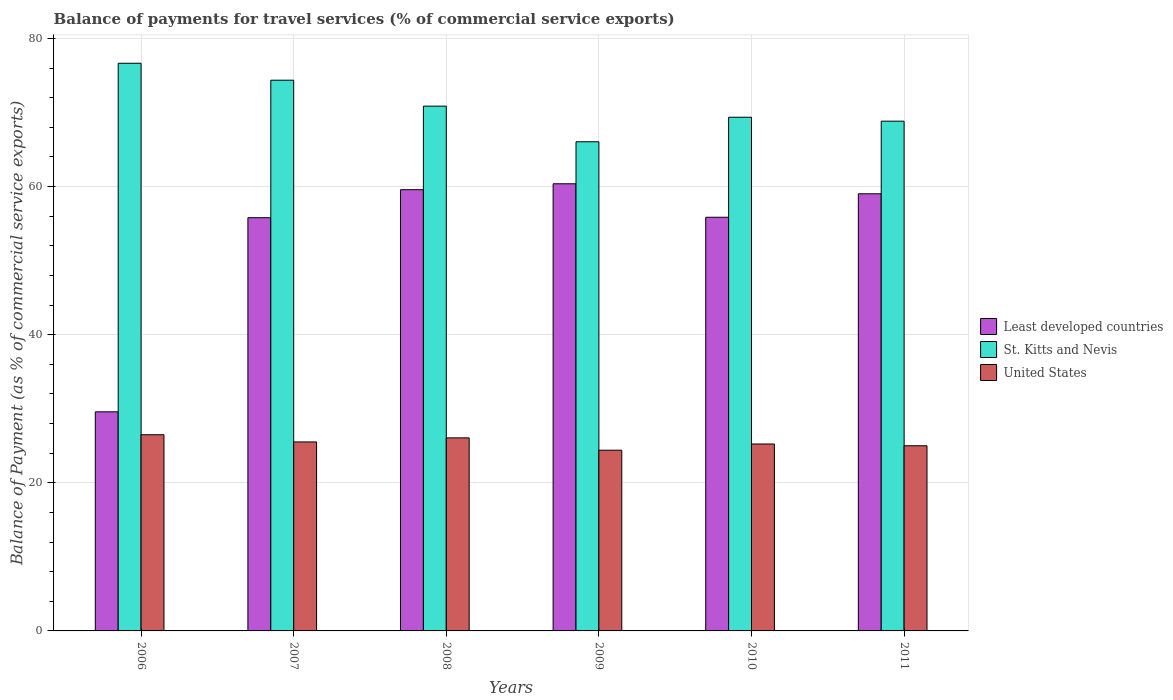How many different coloured bars are there?
Your answer should be very brief. 3. Are the number of bars on each tick of the X-axis equal?
Offer a very short reply. Yes. How many bars are there on the 2nd tick from the right?
Give a very brief answer. 3. What is the balance of payments for travel services in United States in 2009?
Your response must be concise. 24.4. Across all years, what is the maximum balance of payments for travel services in St. Kitts and Nevis?
Your response must be concise. 76.64. Across all years, what is the minimum balance of payments for travel services in Least developed countries?
Provide a short and direct response. 29.58. In which year was the balance of payments for travel services in Least developed countries minimum?
Keep it short and to the point. 2006. What is the total balance of payments for travel services in St. Kitts and Nevis in the graph?
Provide a succinct answer. 426.08. What is the difference between the balance of payments for travel services in United States in 2007 and that in 2010?
Offer a very short reply. 0.28. What is the difference between the balance of payments for travel services in United States in 2008 and the balance of payments for travel services in St. Kitts and Nevis in 2010?
Your response must be concise. -43.29. What is the average balance of payments for travel services in United States per year?
Give a very brief answer. 25.45. In the year 2008, what is the difference between the balance of payments for travel services in United States and balance of payments for travel services in Least developed countries?
Offer a very short reply. -33.51. What is the ratio of the balance of payments for travel services in St. Kitts and Nevis in 2009 to that in 2010?
Offer a terse response. 0.95. Is the balance of payments for travel services in United States in 2006 less than that in 2008?
Provide a short and direct response. No. What is the difference between the highest and the second highest balance of payments for travel services in United States?
Offer a very short reply. 0.42. What is the difference between the highest and the lowest balance of payments for travel services in St. Kitts and Nevis?
Keep it short and to the point. 10.6. In how many years, is the balance of payments for travel services in Least developed countries greater than the average balance of payments for travel services in Least developed countries taken over all years?
Ensure brevity in your answer.  5. Is the sum of the balance of payments for travel services in Least developed countries in 2008 and 2009 greater than the maximum balance of payments for travel services in St. Kitts and Nevis across all years?
Your answer should be very brief. Yes. What does the 1st bar from the left in 2008 represents?
Your response must be concise. Least developed countries. What does the 2nd bar from the right in 2009 represents?
Give a very brief answer. St. Kitts and Nevis. Is it the case that in every year, the sum of the balance of payments for travel services in St. Kitts and Nevis and balance of payments for travel services in United States is greater than the balance of payments for travel services in Least developed countries?
Offer a very short reply. Yes. How many bars are there?
Provide a short and direct response. 18. Are all the bars in the graph horizontal?
Provide a succinct answer. No. How many years are there in the graph?
Your answer should be very brief. 6. How many legend labels are there?
Ensure brevity in your answer.  3. What is the title of the graph?
Your answer should be very brief. Balance of payments for travel services (% of commercial service exports). Does "St. Kitts and Nevis" appear as one of the legend labels in the graph?
Offer a terse response. Yes. What is the label or title of the Y-axis?
Provide a short and direct response. Balance of Payment (as % of commercial service exports). What is the Balance of Payment (as % of commercial service exports) in Least developed countries in 2006?
Give a very brief answer. 29.58. What is the Balance of Payment (as % of commercial service exports) of St. Kitts and Nevis in 2006?
Keep it short and to the point. 76.64. What is the Balance of Payment (as % of commercial service exports) in United States in 2006?
Your answer should be very brief. 26.49. What is the Balance of Payment (as % of commercial service exports) in Least developed countries in 2007?
Your answer should be compact. 55.79. What is the Balance of Payment (as % of commercial service exports) in St. Kitts and Nevis in 2007?
Your answer should be very brief. 74.35. What is the Balance of Payment (as % of commercial service exports) in United States in 2007?
Make the answer very short. 25.52. What is the Balance of Payment (as % of commercial service exports) of Least developed countries in 2008?
Your answer should be very brief. 59.57. What is the Balance of Payment (as % of commercial service exports) of St. Kitts and Nevis in 2008?
Keep it short and to the point. 70.86. What is the Balance of Payment (as % of commercial service exports) in United States in 2008?
Provide a short and direct response. 26.07. What is the Balance of Payment (as % of commercial service exports) of Least developed countries in 2009?
Provide a short and direct response. 60.37. What is the Balance of Payment (as % of commercial service exports) of St. Kitts and Nevis in 2009?
Provide a short and direct response. 66.05. What is the Balance of Payment (as % of commercial service exports) in United States in 2009?
Ensure brevity in your answer.  24.4. What is the Balance of Payment (as % of commercial service exports) in Least developed countries in 2010?
Offer a very short reply. 55.85. What is the Balance of Payment (as % of commercial service exports) in St. Kitts and Nevis in 2010?
Provide a short and direct response. 69.36. What is the Balance of Payment (as % of commercial service exports) in United States in 2010?
Provide a succinct answer. 25.24. What is the Balance of Payment (as % of commercial service exports) in Least developed countries in 2011?
Offer a terse response. 59.02. What is the Balance of Payment (as % of commercial service exports) of St. Kitts and Nevis in 2011?
Ensure brevity in your answer.  68.82. What is the Balance of Payment (as % of commercial service exports) of United States in 2011?
Ensure brevity in your answer.  25. Across all years, what is the maximum Balance of Payment (as % of commercial service exports) in Least developed countries?
Ensure brevity in your answer.  60.37. Across all years, what is the maximum Balance of Payment (as % of commercial service exports) of St. Kitts and Nevis?
Your answer should be compact. 76.64. Across all years, what is the maximum Balance of Payment (as % of commercial service exports) of United States?
Offer a terse response. 26.49. Across all years, what is the minimum Balance of Payment (as % of commercial service exports) in Least developed countries?
Offer a terse response. 29.58. Across all years, what is the minimum Balance of Payment (as % of commercial service exports) in St. Kitts and Nevis?
Provide a succinct answer. 66.05. Across all years, what is the minimum Balance of Payment (as % of commercial service exports) of United States?
Ensure brevity in your answer.  24.4. What is the total Balance of Payment (as % of commercial service exports) of Least developed countries in the graph?
Your answer should be compact. 320.19. What is the total Balance of Payment (as % of commercial service exports) in St. Kitts and Nevis in the graph?
Ensure brevity in your answer.  426.08. What is the total Balance of Payment (as % of commercial service exports) in United States in the graph?
Provide a succinct answer. 152.71. What is the difference between the Balance of Payment (as % of commercial service exports) of Least developed countries in 2006 and that in 2007?
Your answer should be very brief. -26.21. What is the difference between the Balance of Payment (as % of commercial service exports) of St. Kitts and Nevis in 2006 and that in 2007?
Offer a terse response. 2.29. What is the difference between the Balance of Payment (as % of commercial service exports) in United States in 2006 and that in 2007?
Make the answer very short. 0.97. What is the difference between the Balance of Payment (as % of commercial service exports) in Least developed countries in 2006 and that in 2008?
Provide a short and direct response. -29.99. What is the difference between the Balance of Payment (as % of commercial service exports) in St. Kitts and Nevis in 2006 and that in 2008?
Make the answer very short. 5.79. What is the difference between the Balance of Payment (as % of commercial service exports) of United States in 2006 and that in 2008?
Your answer should be compact. 0.42. What is the difference between the Balance of Payment (as % of commercial service exports) in Least developed countries in 2006 and that in 2009?
Ensure brevity in your answer.  -30.79. What is the difference between the Balance of Payment (as % of commercial service exports) in St. Kitts and Nevis in 2006 and that in 2009?
Your answer should be very brief. 10.6. What is the difference between the Balance of Payment (as % of commercial service exports) in United States in 2006 and that in 2009?
Offer a very short reply. 2.09. What is the difference between the Balance of Payment (as % of commercial service exports) in Least developed countries in 2006 and that in 2010?
Offer a terse response. -26.27. What is the difference between the Balance of Payment (as % of commercial service exports) of St. Kitts and Nevis in 2006 and that in 2010?
Give a very brief answer. 7.29. What is the difference between the Balance of Payment (as % of commercial service exports) of United States in 2006 and that in 2010?
Offer a terse response. 1.25. What is the difference between the Balance of Payment (as % of commercial service exports) in Least developed countries in 2006 and that in 2011?
Offer a very short reply. -29.44. What is the difference between the Balance of Payment (as % of commercial service exports) in St. Kitts and Nevis in 2006 and that in 2011?
Offer a terse response. 7.82. What is the difference between the Balance of Payment (as % of commercial service exports) of United States in 2006 and that in 2011?
Give a very brief answer. 1.49. What is the difference between the Balance of Payment (as % of commercial service exports) in Least developed countries in 2007 and that in 2008?
Your answer should be very brief. -3.78. What is the difference between the Balance of Payment (as % of commercial service exports) in St. Kitts and Nevis in 2007 and that in 2008?
Your response must be concise. 3.5. What is the difference between the Balance of Payment (as % of commercial service exports) in United States in 2007 and that in 2008?
Offer a terse response. -0.55. What is the difference between the Balance of Payment (as % of commercial service exports) in Least developed countries in 2007 and that in 2009?
Keep it short and to the point. -4.58. What is the difference between the Balance of Payment (as % of commercial service exports) of St. Kitts and Nevis in 2007 and that in 2009?
Provide a succinct answer. 8.31. What is the difference between the Balance of Payment (as % of commercial service exports) of United States in 2007 and that in 2009?
Provide a short and direct response. 1.12. What is the difference between the Balance of Payment (as % of commercial service exports) in Least developed countries in 2007 and that in 2010?
Provide a short and direct response. -0.06. What is the difference between the Balance of Payment (as % of commercial service exports) of St. Kitts and Nevis in 2007 and that in 2010?
Your response must be concise. 5. What is the difference between the Balance of Payment (as % of commercial service exports) of United States in 2007 and that in 2010?
Your answer should be very brief. 0.28. What is the difference between the Balance of Payment (as % of commercial service exports) of Least developed countries in 2007 and that in 2011?
Give a very brief answer. -3.23. What is the difference between the Balance of Payment (as % of commercial service exports) of St. Kitts and Nevis in 2007 and that in 2011?
Ensure brevity in your answer.  5.53. What is the difference between the Balance of Payment (as % of commercial service exports) in United States in 2007 and that in 2011?
Keep it short and to the point. 0.51. What is the difference between the Balance of Payment (as % of commercial service exports) in Least developed countries in 2008 and that in 2009?
Your response must be concise. -0.8. What is the difference between the Balance of Payment (as % of commercial service exports) in St. Kitts and Nevis in 2008 and that in 2009?
Your answer should be very brief. 4.81. What is the difference between the Balance of Payment (as % of commercial service exports) of United States in 2008 and that in 2009?
Give a very brief answer. 1.67. What is the difference between the Balance of Payment (as % of commercial service exports) of Least developed countries in 2008 and that in 2010?
Provide a succinct answer. 3.72. What is the difference between the Balance of Payment (as % of commercial service exports) in St. Kitts and Nevis in 2008 and that in 2010?
Keep it short and to the point. 1.5. What is the difference between the Balance of Payment (as % of commercial service exports) of United States in 2008 and that in 2010?
Offer a terse response. 0.83. What is the difference between the Balance of Payment (as % of commercial service exports) in Least developed countries in 2008 and that in 2011?
Provide a short and direct response. 0.55. What is the difference between the Balance of Payment (as % of commercial service exports) of St. Kitts and Nevis in 2008 and that in 2011?
Your answer should be compact. 2.03. What is the difference between the Balance of Payment (as % of commercial service exports) in United States in 2008 and that in 2011?
Make the answer very short. 1.07. What is the difference between the Balance of Payment (as % of commercial service exports) of Least developed countries in 2009 and that in 2010?
Keep it short and to the point. 4.52. What is the difference between the Balance of Payment (as % of commercial service exports) of St. Kitts and Nevis in 2009 and that in 2010?
Your answer should be compact. -3.31. What is the difference between the Balance of Payment (as % of commercial service exports) in United States in 2009 and that in 2010?
Your response must be concise. -0.84. What is the difference between the Balance of Payment (as % of commercial service exports) of Least developed countries in 2009 and that in 2011?
Provide a short and direct response. 1.35. What is the difference between the Balance of Payment (as % of commercial service exports) of St. Kitts and Nevis in 2009 and that in 2011?
Give a very brief answer. -2.78. What is the difference between the Balance of Payment (as % of commercial service exports) of United States in 2009 and that in 2011?
Keep it short and to the point. -0.6. What is the difference between the Balance of Payment (as % of commercial service exports) of Least developed countries in 2010 and that in 2011?
Provide a short and direct response. -3.17. What is the difference between the Balance of Payment (as % of commercial service exports) in St. Kitts and Nevis in 2010 and that in 2011?
Your answer should be compact. 0.53. What is the difference between the Balance of Payment (as % of commercial service exports) in United States in 2010 and that in 2011?
Provide a succinct answer. 0.24. What is the difference between the Balance of Payment (as % of commercial service exports) of Least developed countries in 2006 and the Balance of Payment (as % of commercial service exports) of St. Kitts and Nevis in 2007?
Your answer should be compact. -44.77. What is the difference between the Balance of Payment (as % of commercial service exports) in Least developed countries in 2006 and the Balance of Payment (as % of commercial service exports) in United States in 2007?
Make the answer very short. 4.06. What is the difference between the Balance of Payment (as % of commercial service exports) of St. Kitts and Nevis in 2006 and the Balance of Payment (as % of commercial service exports) of United States in 2007?
Ensure brevity in your answer.  51.13. What is the difference between the Balance of Payment (as % of commercial service exports) in Least developed countries in 2006 and the Balance of Payment (as % of commercial service exports) in St. Kitts and Nevis in 2008?
Keep it short and to the point. -41.27. What is the difference between the Balance of Payment (as % of commercial service exports) in Least developed countries in 2006 and the Balance of Payment (as % of commercial service exports) in United States in 2008?
Offer a terse response. 3.51. What is the difference between the Balance of Payment (as % of commercial service exports) in St. Kitts and Nevis in 2006 and the Balance of Payment (as % of commercial service exports) in United States in 2008?
Ensure brevity in your answer.  50.58. What is the difference between the Balance of Payment (as % of commercial service exports) of Least developed countries in 2006 and the Balance of Payment (as % of commercial service exports) of St. Kitts and Nevis in 2009?
Ensure brevity in your answer.  -36.46. What is the difference between the Balance of Payment (as % of commercial service exports) of Least developed countries in 2006 and the Balance of Payment (as % of commercial service exports) of United States in 2009?
Your answer should be compact. 5.18. What is the difference between the Balance of Payment (as % of commercial service exports) in St. Kitts and Nevis in 2006 and the Balance of Payment (as % of commercial service exports) in United States in 2009?
Your response must be concise. 52.24. What is the difference between the Balance of Payment (as % of commercial service exports) of Least developed countries in 2006 and the Balance of Payment (as % of commercial service exports) of St. Kitts and Nevis in 2010?
Your answer should be very brief. -39.77. What is the difference between the Balance of Payment (as % of commercial service exports) in Least developed countries in 2006 and the Balance of Payment (as % of commercial service exports) in United States in 2010?
Keep it short and to the point. 4.34. What is the difference between the Balance of Payment (as % of commercial service exports) of St. Kitts and Nevis in 2006 and the Balance of Payment (as % of commercial service exports) of United States in 2010?
Offer a very short reply. 51.41. What is the difference between the Balance of Payment (as % of commercial service exports) of Least developed countries in 2006 and the Balance of Payment (as % of commercial service exports) of St. Kitts and Nevis in 2011?
Offer a terse response. -39.24. What is the difference between the Balance of Payment (as % of commercial service exports) in Least developed countries in 2006 and the Balance of Payment (as % of commercial service exports) in United States in 2011?
Offer a terse response. 4.58. What is the difference between the Balance of Payment (as % of commercial service exports) of St. Kitts and Nevis in 2006 and the Balance of Payment (as % of commercial service exports) of United States in 2011?
Provide a short and direct response. 51.64. What is the difference between the Balance of Payment (as % of commercial service exports) of Least developed countries in 2007 and the Balance of Payment (as % of commercial service exports) of St. Kitts and Nevis in 2008?
Make the answer very short. -15.06. What is the difference between the Balance of Payment (as % of commercial service exports) of Least developed countries in 2007 and the Balance of Payment (as % of commercial service exports) of United States in 2008?
Ensure brevity in your answer.  29.73. What is the difference between the Balance of Payment (as % of commercial service exports) of St. Kitts and Nevis in 2007 and the Balance of Payment (as % of commercial service exports) of United States in 2008?
Offer a very short reply. 48.29. What is the difference between the Balance of Payment (as % of commercial service exports) in Least developed countries in 2007 and the Balance of Payment (as % of commercial service exports) in St. Kitts and Nevis in 2009?
Provide a short and direct response. -10.25. What is the difference between the Balance of Payment (as % of commercial service exports) of Least developed countries in 2007 and the Balance of Payment (as % of commercial service exports) of United States in 2009?
Give a very brief answer. 31.39. What is the difference between the Balance of Payment (as % of commercial service exports) in St. Kitts and Nevis in 2007 and the Balance of Payment (as % of commercial service exports) in United States in 2009?
Offer a terse response. 49.96. What is the difference between the Balance of Payment (as % of commercial service exports) of Least developed countries in 2007 and the Balance of Payment (as % of commercial service exports) of St. Kitts and Nevis in 2010?
Your answer should be compact. -13.56. What is the difference between the Balance of Payment (as % of commercial service exports) of Least developed countries in 2007 and the Balance of Payment (as % of commercial service exports) of United States in 2010?
Keep it short and to the point. 30.55. What is the difference between the Balance of Payment (as % of commercial service exports) in St. Kitts and Nevis in 2007 and the Balance of Payment (as % of commercial service exports) in United States in 2010?
Provide a succinct answer. 49.12. What is the difference between the Balance of Payment (as % of commercial service exports) in Least developed countries in 2007 and the Balance of Payment (as % of commercial service exports) in St. Kitts and Nevis in 2011?
Ensure brevity in your answer.  -13.03. What is the difference between the Balance of Payment (as % of commercial service exports) in Least developed countries in 2007 and the Balance of Payment (as % of commercial service exports) in United States in 2011?
Your answer should be very brief. 30.79. What is the difference between the Balance of Payment (as % of commercial service exports) in St. Kitts and Nevis in 2007 and the Balance of Payment (as % of commercial service exports) in United States in 2011?
Give a very brief answer. 49.35. What is the difference between the Balance of Payment (as % of commercial service exports) in Least developed countries in 2008 and the Balance of Payment (as % of commercial service exports) in St. Kitts and Nevis in 2009?
Your answer should be very brief. -6.47. What is the difference between the Balance of Payment (as % of commercial service exports) of Least developed countries in 2008 and the Balance of Payment (as % of commercial service exports) of United States in 2009?
Your response must be concise. 35.17. What is the difference between the Balance of Payment (as % of commercial service exports) of St. Kitts and Nevis in 2008 and the Balance of Payment (as % of commercial service exports) of United States in 2009?
Keep it short and to the point. 46.46. What is the difference between the Balance of Payment (as % of commercial service exports) in Least developed countries in 2008 and the Balance of Payment (as % of commercial service exports) in St. Kitts and Nevis in 2010?
Provide a short and direct response. -9.78. What is the difference between the Balance of Payment (as % of commercial service exports) in Least developed countries in 2008 and the Balance of Payment (as % of commercial service exports) in United States in 2010?
Provide a succinct answer. 34.34. What is the difference between the Balance of Payment (as % of commercial service exports) of St. Kitts and Nevis in 2008 and the Balance of Payment (as % of commercial service exports) of United States in 2010?
Ensure brevity in your answer.  45.62. What is the difference between the Balance of Payment (as % of commercial service exports) in Least developed countries in 2008 and the Balance of Payment (as % of commercial service exports) in St. Kitts and Nevis in 2011?
Your answer should be very brief. -9.25. What is the difference between the Balance of Payment (as % of commercial service exports) of Least developed countries in 2008 and the Balance of Payment (as % of commercial service exports) of United States in 2011?
Give a very brief answer. 34.57. What is the difference between the Balance of Payment (as % of commercial service exports) in St. Kitts and Nevis in 2008 and the Balance of Payment (as % of commercial service exports) in United States in 2011?
Provide a short and direct response. 45.85. What is the difference between the Balance of Payment (as % of commercial service exports) of Least developed countries in 2009 and the Balance of Payment (as % of commercial service exports) of St. Kitts and Nevis in 2010?
Provide a succinct answer. -8.98. What is the difference between the Balance of Payment (as % of commercial service exports) in Least developed countries in 2009 and the Balance of Payment (as % of commercial service exports) in United States in 2010?
Offer a terse response. 35.13. What is the difference between the Balance of Payment (as % of commercial service exports) of St. Kitts and Nevis in 2009 and the Balance of Payment (as % of commercial service exports) of United States in 2010?
Provide a short and direct response. 40.81. What is the difference between the Balance of Payment (as % of commercial service exports) in Least developed countries in 2009 and the Balance of Payment (as % of commercial service exports) in St. Kitts and Nevis in 2011?
Ensure brevity in your answer.  -8.45. What is the difference between the Balance of Payment (as % of commercial service exports) in Least developed countries in 2009 and the Balance of Payment (as % of commercial service exports) in United States in 2011?
Provide a succinct answer. 35.37. What is the difference between the Balance of Payment (as % of commercial service exports) of St. Kitts and Nevis in 2009 and the Balance of Payment (as % of commercial service exports) of United States in 2011?
Provide a succinct answer. 41.04. What is the difference between the Balance of Payment (as % of commercial service exports) of Least developed countries in 2010 and the Balance of Payment (as % of commercial service exports) of St. Kitts and Nevis in 2011?
Your answer should be compact. -12.97. What is the difference between the Balance of Payment (as % of commercial service exports) in Least developed countries in 2010 and the Balance of Payment (as % of commercial service exports) in United States in 2011?
Your response must be concise. 30.85. What is the difference between the Balance of Payment (as % of commercial service exports) of St. Kitts and Nevis in 2010 and the Balance of Payment (as % of commercial service exports) of United States in 2011?
Your answer should be compact. 44.35. What is the average Balance of Payment (as % of commercial service exports) of Least developed countries per year?
Offer a very short reply. 53.37. What is the average Balance of Payment (as % of commercial service exports) in St. Kitts and Nevis per year?
Ensure brevity in your answer.  71.01. What is the average Balance of Payment (as % of commercial service exports) in United States per year?
Keep it short and to the point. 25.45. In the year 2006, what is the difference between the Balance of Payment (as % of commercial service exports) in Least developed countries and Balance of Payment (as % of commercial service exports) in St. Kitts and Nevis?
Your answer should be compact. -47.06. In the year 2006, what is the difference between the Balance of Payment (as % of commercial service exports) in Least developed countries and Balance of Payment (as % of commercial service exports) in United States?
Provide a short and direct response. 3.09. In the year 2006, what is the difference between the Balance of Payment (as % of commercial service exports) of St. Kitts and Nevis and Balance of Payment (as % of commercial service exports) of United States?
Provide a succinct answer. 50.16. In the year 2007, what is the difference between the Balance of Payment (as % of commercial service exports) of Least developed countries and Balance of Payment (as % of commercial service exports) of St. Kitts and Nevis?
Ensure brevity in your answer.  -18.56. In the year 2007, what is the difference between the Balance of Payment (as % of commercial service exports) of Least developed countries and Balance of Payment (as % of commercial service exports) of United States?
Offer a very short reply. 30.28. In the year 2007, what is the difference between the Balance of Payment (as % of commercial service exports) of St. Kitts and Nevis and Balance of Payment (as % of commercial service exports) of United States?
Provide a succinct answer. 48.84. In the year 2008, what is the difference between the Balance of Payment (as % of commercial service exports) in Least developed countries and Balance of Payment (as % of commercial service exports) in St. Kitts and Nevis?
Your response must be concise. -11.28. In the year 2008, what is the difference between the Balance of Payment (as % of commercial service exports) of Least developed countries and Balance of Payment (as % of commercial service exports) of United States?
Give a very brief answer. 33.51. In the year 2008, what is the difference between the Balance of Payment (as % of commercial service exports) in St. Kitts and Nevis and Balance of Payment (as % of commercial service exports) in United States?
Keep it short and to the point. 44.79. In the year 2009, what is the difference between the Balance of Payment (as % of commercial service exports) in Least developed countries and Balance of Payment (as % of commercial service exports) in St. Kitts and Nevis?
Provide a succinct answer. -5.67. In the year 2009, what is the difference between the Balance of Payment (as % of commercial service exports) of Least developed countries and Balance of Payment (as % of commercial service exports) of United States?
Make the answer very short. 35.97. In the year 2009, what is the difference between the Balance of Payment (as % of commercial service exports) in St. Kitts and Nevis and Balance of Payment (as % of commercial service exports) in United States?
Make the answer very short. 41.65. In the year 2010, what is the difference between the Balance of Payment (as % of commercial service exports) in Least developed countries and Balance of Payment (as % of commercial service exports) in St. Kitts and Nevis?
Your answer should be very brief. -13.5. In the year 2010, what is the difference between the Balance of Payment (as % of commercial service exports) of Least developed countries and Balance of Payment (as % of commercial service exports) of United States?
Ensure brevity in your answer.  30.61. In the year 2010, what is the difference between the Balance of Payment (as % of commercial service exports) in St. Kitts and Nevis and Balance of Payment (as % of commercial service exports) in United States?
Provide a succinct answer. 44.12. In the year 2011, what is the difference between the Balance of Payment (as % of commercial service exports) in Least developed countries and Balance of Payment (as % of commercial service exports) in St. Kitts and Nevis?
Offer a very short reply. -9.8. In the year 2011, what is the difference between the Balance of Payment (as % of commercial service exports) of Least developed countries and Balance of Payment (as % of commercial service exports) of United States?
Keep it short and to the point. 34.02. In the year 2011, what is the difference between the Balance of Payment (as % of commercial service exports) of St. Kitts and Nevis and Balance of Payment (as % of commercial service exports) of United States?
Give a very brief answer. 43.82. What is the ratio of the Balance of Payment (as % of commercial service exports) in Least developed countries in 2006 to that in 2007?
Offer a terse response. 0.53. What is the ratio of the Balance of Payment (as % of commercial service exports) of St. Kitts and Nevis in 2006 to that in 2007?
Provide a succinct answer. 1.03. What is the ratio of the Balance of Payment (as % of commercial service exports) of United States in 2006 to that in 2007?
Ensure brevity in your answer.  1.04. What is the ratio of the Balance of Payment (as % of commercial service exports) of Least developed countries in 2006 to that in 2008?
Offer a terse response. 0.5. What is the ratio of the Balance of Payment (as % of commercial service exports) in St. Kitts and Nevis in 2006 to that in 2008?
Give a very brief answer. 1.08. What is the ratio of the Balance of Payment (as % of commercial service exports) of United States in 2006 to that in 2008?
Your response must be concise. 1.02. What is the ratio of the Balance of Payment (as % of commercial service exports) in Least developed countries in 2006 to that in 2009?
Provide a succinct answer. 0.49. What is the ratio of the Balance of Payment (as % of commercial service exports) in St. Kitts and Nevis in 2006 to that in 2009?
Your response must be concise. 1.16. What is the ratio of the Balance of Payment (as % of commercial service exports) in United States in 2006 to that in 2009?
Offer a very short reply. 1.09. What is the ratio of the Balance of Payment (as % of commercial service exports) in Least developed countries in 2006 to that in 2010?
Your answer should be compact. 0.53. What is the ratio of the Balance of Payment (as % of commercial service exports) in St. Kitts and Nevis in 2006 to that in 2010?
Your answer should be compact. 1.11. What is the ratio of the Balance of Payment (as % of commercial service exports) of United States in 2006 to that in 2010?
Provide a short and direct response. 1.05. What is the ratio of the Balance of Payment (as % of commercial service exports) of Least developed countries in 2006 to that in 2011?
Your answer should be very brief. 0.5. What is the ratio of the Balance of Payment (as % of commercial service exports) in St. Kitts and Nevis in 2006 to that in 2011?
Give a very brief answer. 1.11. What is the ratio of the Balance of Payment (as % of commercial service exports) in United States in 2006 to that in 2011?
Your answer should be compact. 1.06. What is the ratio of the Balance of Payment (as % of commercial service exports) of Least developed countries in 2007 to that in 2008?
Make the answer very short. 0.94. What is the ratio of the Balance of Payment (as % of commercial service exports) of St. Kitts and Nevis in 2007 to that in 2008?
Your response must be concise. 1.05. What is the ratio of the Balance of Payment (as % of commercial service exports) in United States in 2007 to that in 2008?
Your response must be concise. 0.98. What is the ratio of the Balance of Payment (as % of commercial service exports) of Least developed countries in 2007 to that in 2009?
Give a very brief answer. 0.92. What is the ratio of the Balance of Payment (as % of commercial service exports) in St. Kitts and Nevis in 2007 to that in 2009?
Provide a short and direct response. 1.13. What is the ratio of the Balance of Payment (as % of commercial service exports) of United States in 2007 to that in 2009?
Your response must be concise. 1.05. What is the ratio of the Balance of Payment (as % of commercial service exports) in Least developed countries in 2007 to that in 2010?
Keep it short and to the point. 1. What is the ratio of the Balance of Payment (as % of commercial service exports) of St. Kitts and Nevis in 2007 to that in 2010?
Keep it short and to the point. 1.07. What is the ratio of the Balance of Payment (as % of commercial service exports) in United States in 2007 to that in 2010?
Provide a succinct answer. 1.01. What is the ratio of the Balance of Payment (as % of commercial service exports) in Least developed countries in 2007 to that in 2011?
Make the answer very short. 0.95. What is the ratio of the Balance of Payment (as % of commercial service exports) of St. Kitts and Nevis in 2007 to that in 2011?
Keep it short and to the point. 1.08. What is the ratio of the Balance of Payment (as % of commercial service exports) in United States in 2007 to that in 2011?
Offer a very short reply. 1.02. What is the ratio of the Balance of Payment (as % of commercial service exports) in Least developed countries in 2008 to that in 2009?
Your answer should be very brief. 0.99. What is the ratio of the Balance of Payment (as % of commercial service exports) of St. Kitts and Nevis in 2008 to that in 2009?
Your answer should be very brief. 1.07. What is the ratio of the Balance of Payment (as % of commercial service exports) of United States in 2008 to that in 2009?
Give a very brief answer. 1.07. What is the ratio of the Balance of Payment (as % of commercial service exports) of Least developed countries in 2008 to that in 2010?
Give a very brief answer. 1.07. What is the ratio of the Balance of Payment (as % of commercial service exports) of St. Kitts and Nevis in 2008 to that in 2010?
Provide a short and direct response. 1.02. What is the ratio of the Balance of Payment (as % of commercial service exports) in United States in 2008 to that in 2010?
Your answer should be compact. 1.03. What is the ratio of the Balance of Payment (as % of commercial service exports) of Least developed countries in 2008 to that in 2011?
Your answer should be very brief. 1.01. What is the ratio of the Balance of Payment (as % of commercial service exports) of St. Kitts and Nevis in 2008 to that in 2011?
Provide a short and direct response. 1.03. What is the ratio of the Balance of Payment (as % of commercial service exports) in United States in 2008 to that in 2011?
Keep it short and to the point. 1.04. What is the ratio of the Balance of Payment (as % of commercial service exports) in Least developed countries in 2009 to that in 2010?
Give a very brief answer. 1.08. What is the ratio of the Balance of Payment (as % of commercial service exports) in St. Kitts and Nevis in 2009 to that in 2010?
Give a very brief answer. 0.95. What is the ratio of the Balance of Payment (as % of commercial service exports) of United States in 2009 to that in 2010?
Ensure brevity in your answer.  0.97. What is the ratio of the Balance of Payment (as % of commercial service exports) in Least developed countries in 2009 to that in 2011?
Offer a terse response. 1.02. What is the ratio of the Balance of Payment (as % of commercial service exports) of St. Kitts and Nevis in 2009 to that in 2011?
Provide a succinct answer. 0.96. What is the ratio of the Balance of Payment (as % of commercial service exports) of United States in 2009 to that in 2011?
Offer a terse response. 0.98. What is the ratio of the Balance of Payment (as % of commercial service exports) in Least developed countries in 2010 to that in 2011?
Offer a terse response. 0.95. What is the ratio of the Balance of Payment (as % of commercial service exports) of St. Kitts and Nevis in 2010 to that in 2011?
Keep it short and to the point. 1.01. What is the ratio of the Balance of Payment (as % of commercial service exports) in United States in 2010 to that in 2011?
Your answer should be compact. 1.01. What is the difference between the highest and the second highest Balance of Payment (as % of commercial service exports) in Least developed countries?
Keep it short and to the point. 0.8. What is the difference between the highest and the second highest Balance of Payment (as % of commercial service exports) of St. Kitts and Nevis?
Your response must be concise. 2.29. What is the difference between the highest and the second highest Balance of Payment (as % of commercial service exports) in United States?
Offer a very short reply. 0.42. What is the difference between the highest and the lowest Balance of Payment (as % of commercial service exports) in Least developed countries?
Offer a terse response. 30.79. What is the difference between the highest and the lowest Balance of Payment (as % of commercial service exports) in St. Kitts and Nevis?
Offer a very short reply. 10.6. What is the difference between the highest and the lowest Balance of Payment (as % of commercial service exports) of United States?
Ensure brevity in your answer.  2.09. 